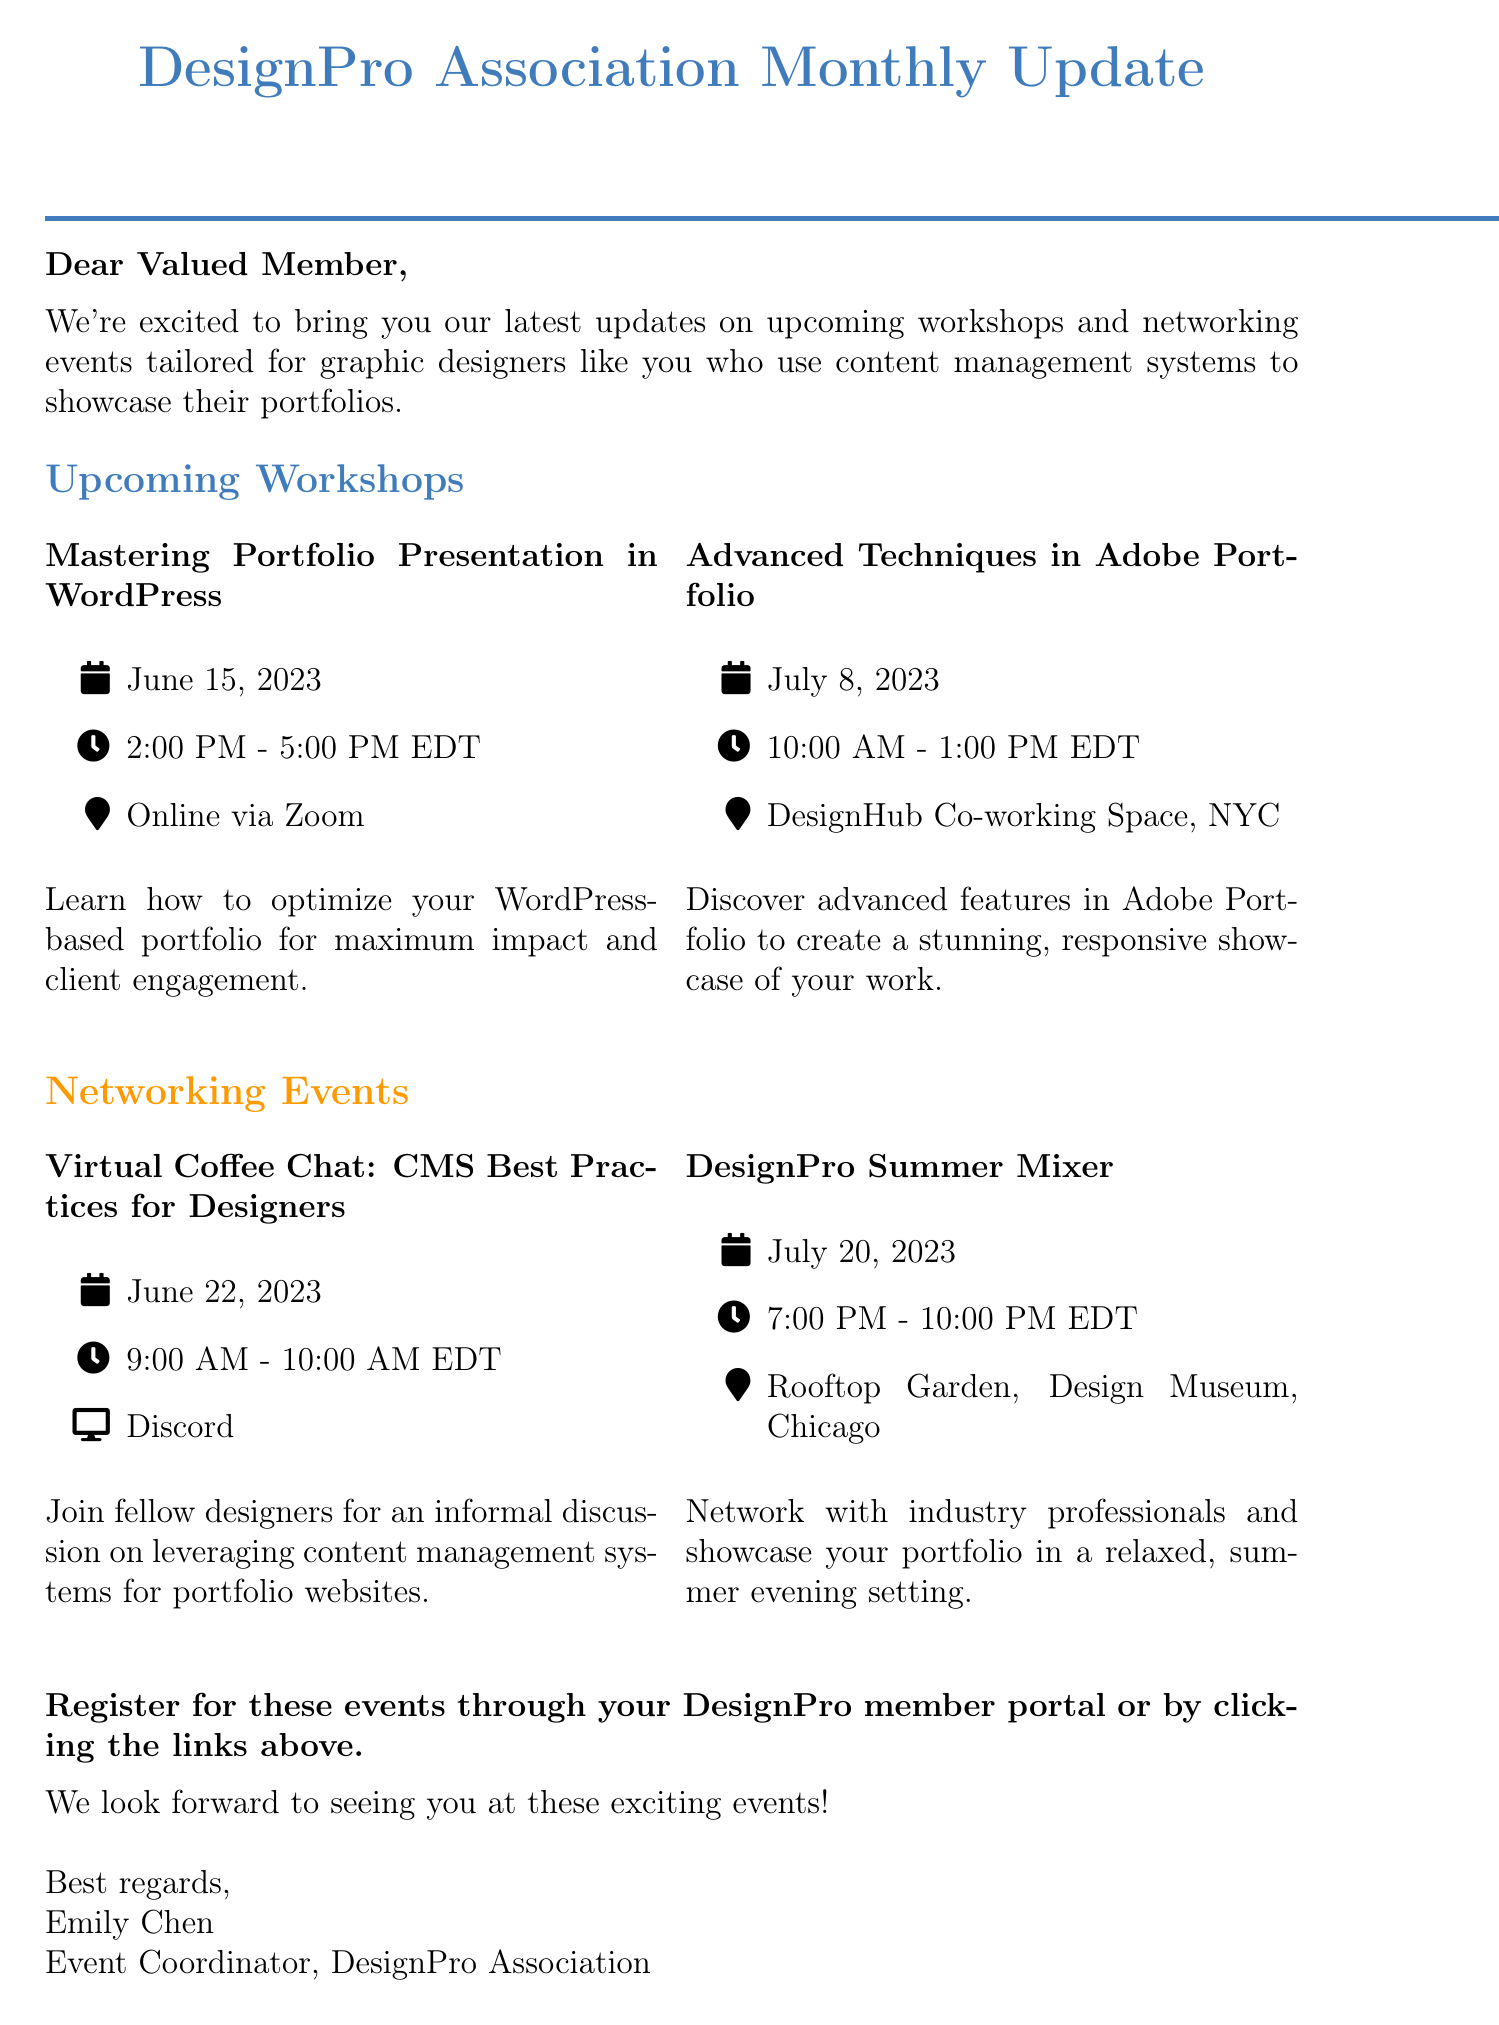What is the title of the newsletter? The title of the newsletter is mentioned prominently at the beginning of the document.
Answer: DesignPro Association Monthly Update Who is the Event Coordinator? The name of the Event Coordinator is provided in the closing section of the newsletter.
Answer: Emily Chen When is the "Mastering Portfolio Presentation in WordPress" workshop? The date of the workshop is specified under the workshop section of the document.
Answer: June 15, 2023 Where will the "Advanced Techniques in Adobe Portfolio" workshop take place? The location of the workshop is included in the workshop details.
Answer: DesignHub Co-working Space, New York City What platform will be used for the "Virtual Coffee Chat" networking event? The platform for the networking event is listed in the networking events section.
Answer: Discord How long is the "DesignPro Summer Mixer"? The duration of the networking event is indicated in the event details.
Answer: 3 hours What type of professional event is the "DesignPro Summer Mixer"? The nature of the event is described in the networking events section.
Answer: Networking What is the primary audience for the newsletter? The audience is described in the introduction of the newsletter, which specifies the target group.
Answer: Graphic designers When is the "Advanced Techniques in Adobe Portfolio" workshop scheduled? The date of the workshop is explicitly mentioned in its details.
Answer: July 8, 2023 